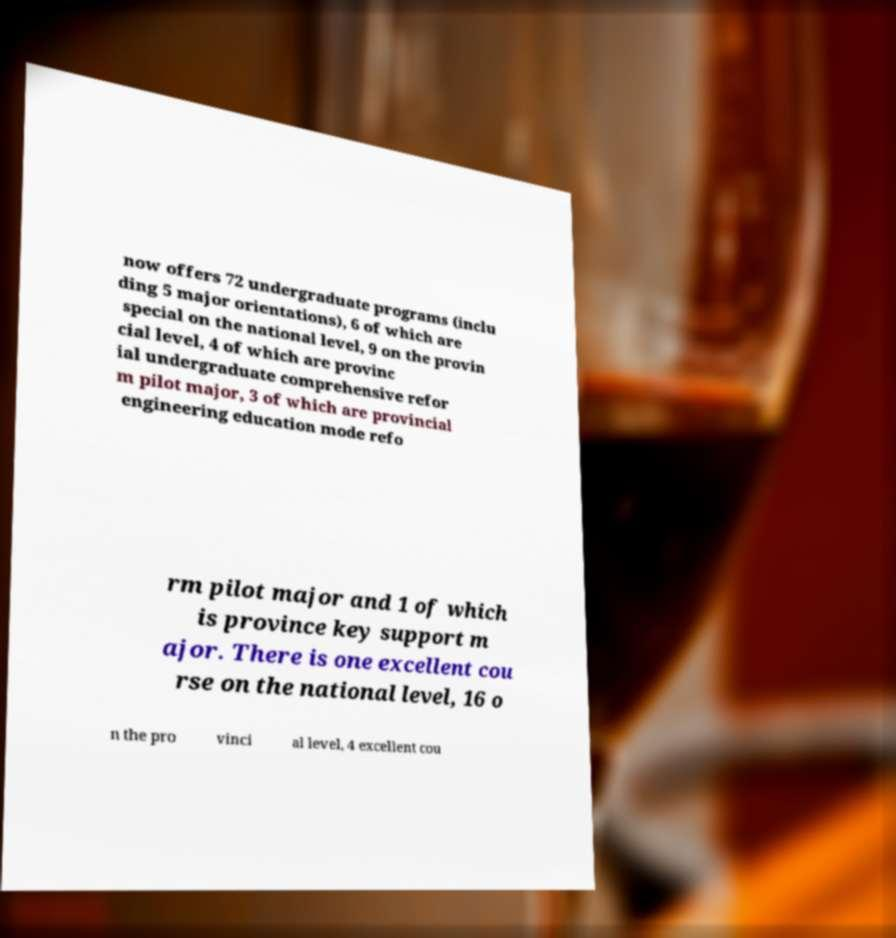There's text embedded in this image that I need extracted. Can you transcribe it verbatim? now offers 72 undergraduate programs (inclu ding 5 major orientations), 6 of which are special on the national level, 9 on the provin cial level, 4 of which are provinc ial undergraduate comprehensive refor m pilot major, 3 of which are provincial engineering education mode refo rm pilot major and 1 of which is province key support m ajor. There is one excellent cou rse on the national level, 16 o n the pro vinci al level, 4 excellent cou 